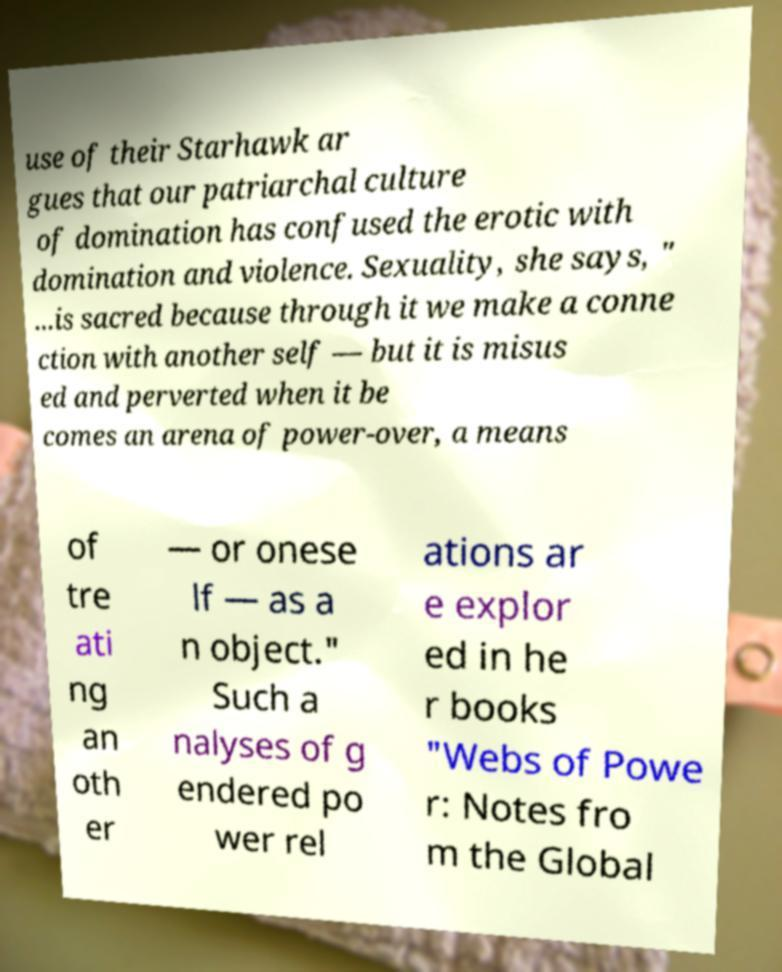There's text embedded in this image that I need extracted. Can you transcribe it verbatim? use of their Starhawk ar gues that our patriarchal culture of domination has confused the erotic with domination and violence. Sexuality, she says, " ...is sacred because through it we make a conne ction with another self — but it is misus ed and perverted when it be comes an arena of power-over, a means of tre ati ng an oth er — or onese lf — as a n object." Such a nalyses of g endered po wer rel ations ar e explor ed in he r books "Webs of Powe r: Notes fro m the Global 